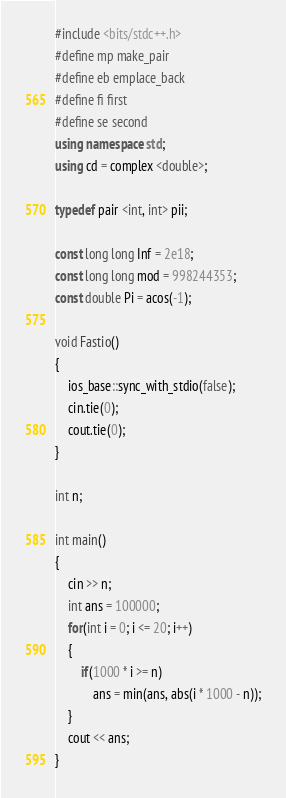<code> <loc_0><loc_0><loc_500><loc_500><_C++_>#include <bits/stdc++.h>
#define mp make_pair
#define eb emplace_back
#define fi first
#define se second
using namespace std;
using cd = complex <double>;
 
typedef pair <int, int> pii;
 
const long long Inf = 2e18;
const long long mod = 998244353;
const double Pi = acos(-1);
 
void Fastio()
{
	ios_base::sync_with_stdio(false);
	cin.tie(0);
	cout.tie(0);
}

int n;

int main()
{
	cin >> n;
	int ans = 100000;
	for(int i = 0; i <= 20; i++)
	{
		if(1000 * i >= n)
			ans = min(ans, abs(i * 1000 - n));
	}
	cout << ans;
}</code> 